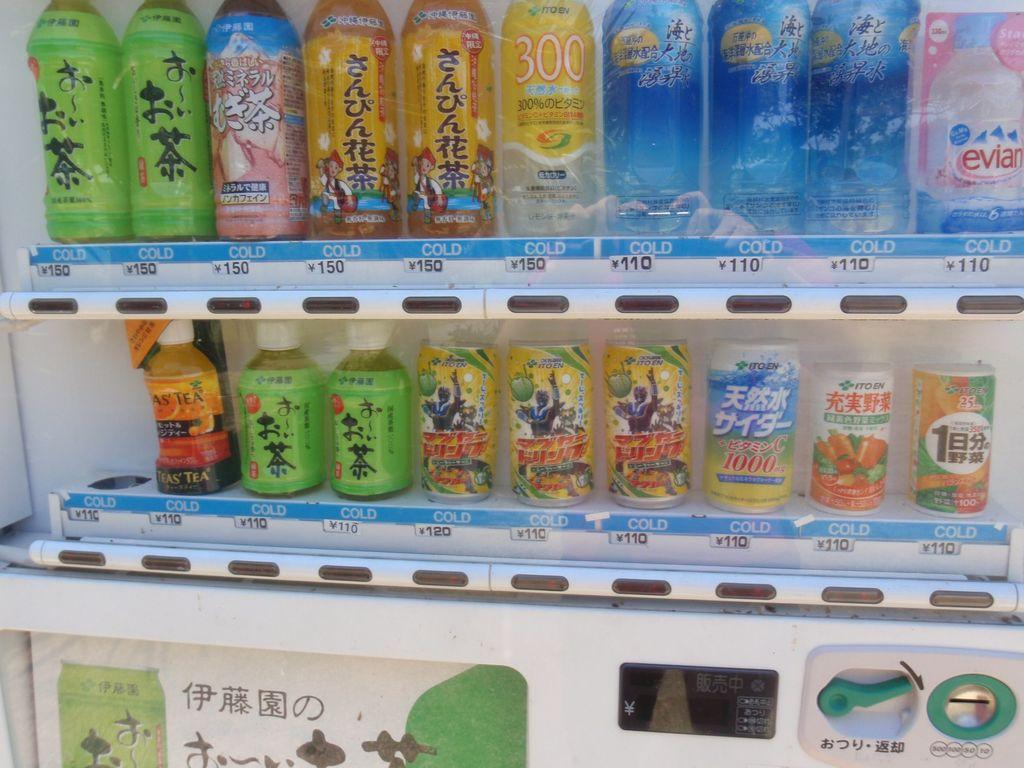What objects are present in the image? There are bottles in the image. Can you describe the bottles in the image? Unfortunately, the provided facts do not offer any additional details about the bottles. Are there any other objects or elements in the image besides the bottles? The given facts do not mention any other objects or elements in the image. What type of silk is being used to wrap the toad in the image? There is no toad or silk present in the image; it only features bottles. 